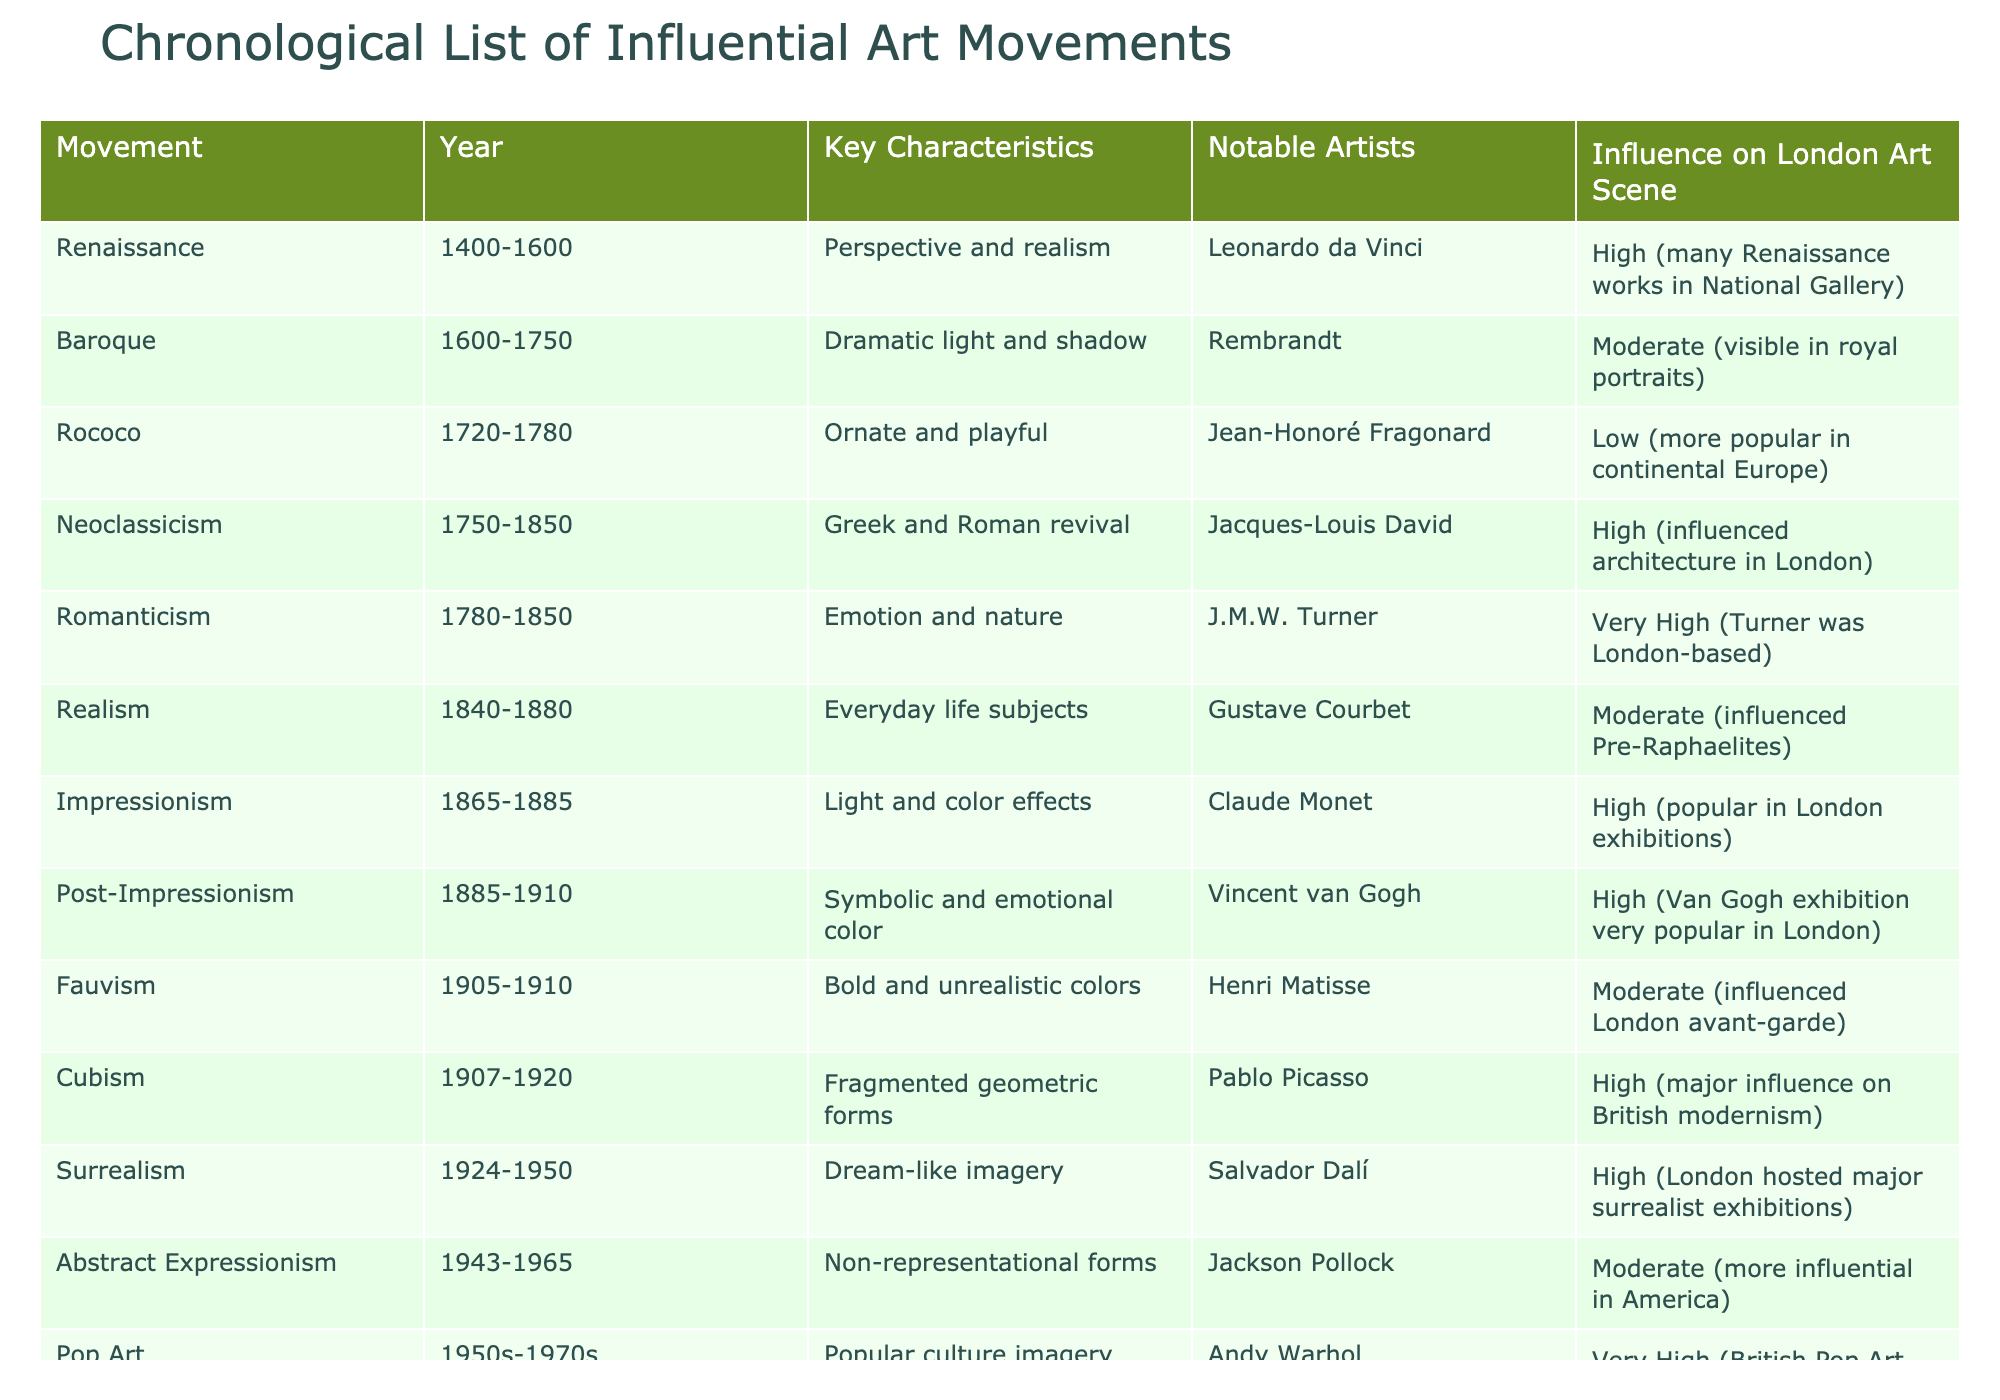What are the key characteristics of Cubism? According to the table, Cubism is characterized by fragmented geometric forms.
Answer: Fragmented geometric forms Which art movement is known for its dramatic light and shadow? The table indicates that the Baroque movement is known for dramatic light and shadow.
Answer: Baroque Which notable artist is associated with Romanticism? The table shows that J.M.W. Turner is a notable artist associated with Romanticism.
Answer: J.M.W. Turner How many art movements influenced the London art scene with a high degree? The table lists 6 movements (Renaissance, Neoclassicism, Romanticism, Impressionism, Post-Impressionism, Cubism, Surrealism, and Pop Art) with a high influence on the London art scene, totaling 8.
Answer: 8 Is Rococo considered to have had a high influence on the London art scene? According to the table, Rococo had a low influence on the London art scene.
Answer: No What movement came after Impressionism and what are its key characteristics? The movement that came after Impressionism is Post-Impressionism, which is characterized by symbolic and emotional color.
Answer: Post-Impressionism; Symbolic and emotional color Which two movements share the same timeframe from 1960s to 1970s? Minimalism and Conceptual Art are both labeled within the timeframe of the 1960s to 1970s according to the table.
Answer: Minimalism and Conceptual Art Which movement had the least influence on the London art scene? The table indicates Rococo had the least influence, categorized as low.
Answer: Rococo How does the influence on the London art scene of Abstract Expressionism compare to that of Cubism? The table shows that Abstract Expressionism is moderate in influence while Cubism is high, indicating that Cubism had a stronger effect on the London art scene than Abstract Expressionism.
Answer: Cubism had a stronger effect List the art movements that focused on emotional expression. The art movements that emphasize emotional expression are Romanticism and Post-Impressionism, as indicated in the table.
Answer: Romanticism and Post-Impressionism 